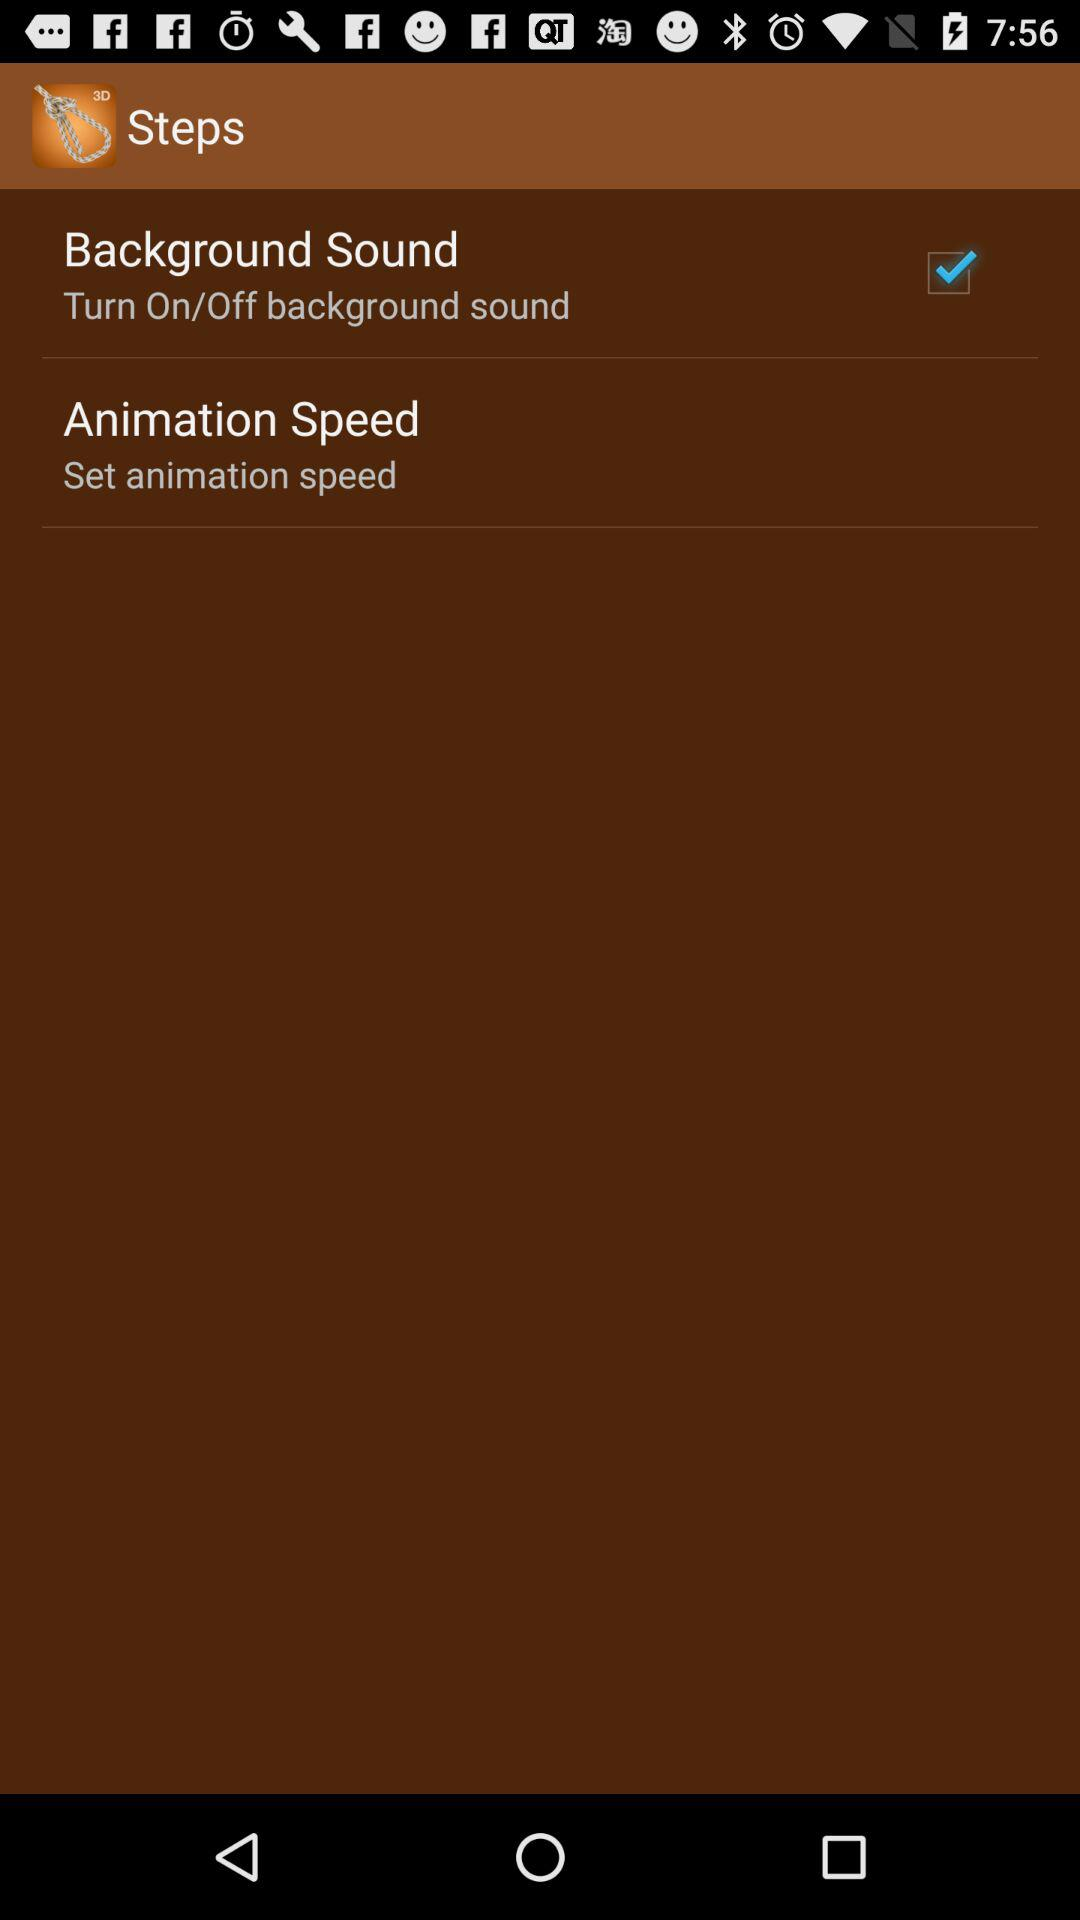What is the name of the application? The name of the application is "Steps". 